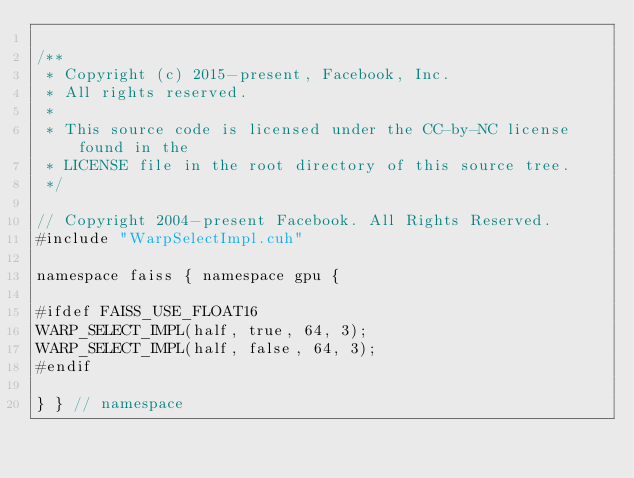Convert code to text. <code><loc_0><loc_0><loc_500><loc_500><_Cuda_>
/**
 * Copyright (c) 2015-present, Facebook, Inc.
 * All rights reserved.
 *
 * This source code is licensed under the CC-by-NC license found in the
 * LICENSE file in the root directory of this source tree.
 */

// Copyright 2004-present Facebook. All Rights Reserved.
#include "WarpSelectImpl.cuh"

namespace faiss { namespace gpu {

#ifdef FAISS_USE_FLOAT16
WARP_SELECT_IMPL(half, true, 64, 3);
WARP_SELECT_IMPL(half, false, 64, 3);
#endif

} } // namespace
</code> 